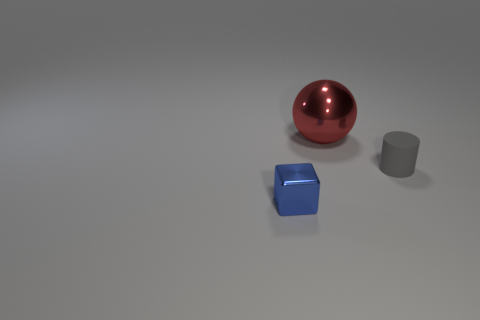What number of other things are the same size as the blue metallic cube?
Make the answer very short. 1. There is a tiny thing in front of the small thing to the right of the object that is behind the tiny rubber cylinder; what is its material?
Give a very brief answer. Metal. Does the metal thing that is to the left of the red metal object have the same shape as the metallic object behind the tiny gray object?
Your answer should be very brief. No. What color is the shiny thing that is on the left side of the metal object to the right of the blue cube?
Give a very brief answer. Blue. What number of balls are big gray matte objects or big objects?
Your answer should be very brief. 1. What number of blue things are behind the tiny object that is behind the small object that is on the left side of the rubber thing?
Ensure brevity in your answer.  0. Are there any large red spheres that have the same material as the small blue object?
Offer a very short reply. Yes. Does the tiny cylinder have the same material as the large red ball?
Make the answer very short. No. What number of tiny cylinders are on the left side of the thing behind the tiny matte object?
Provide a succinct answer. 0. How many brown things are either small matte objects or metal spheres?
Ensure brevity in your answer.  0. 